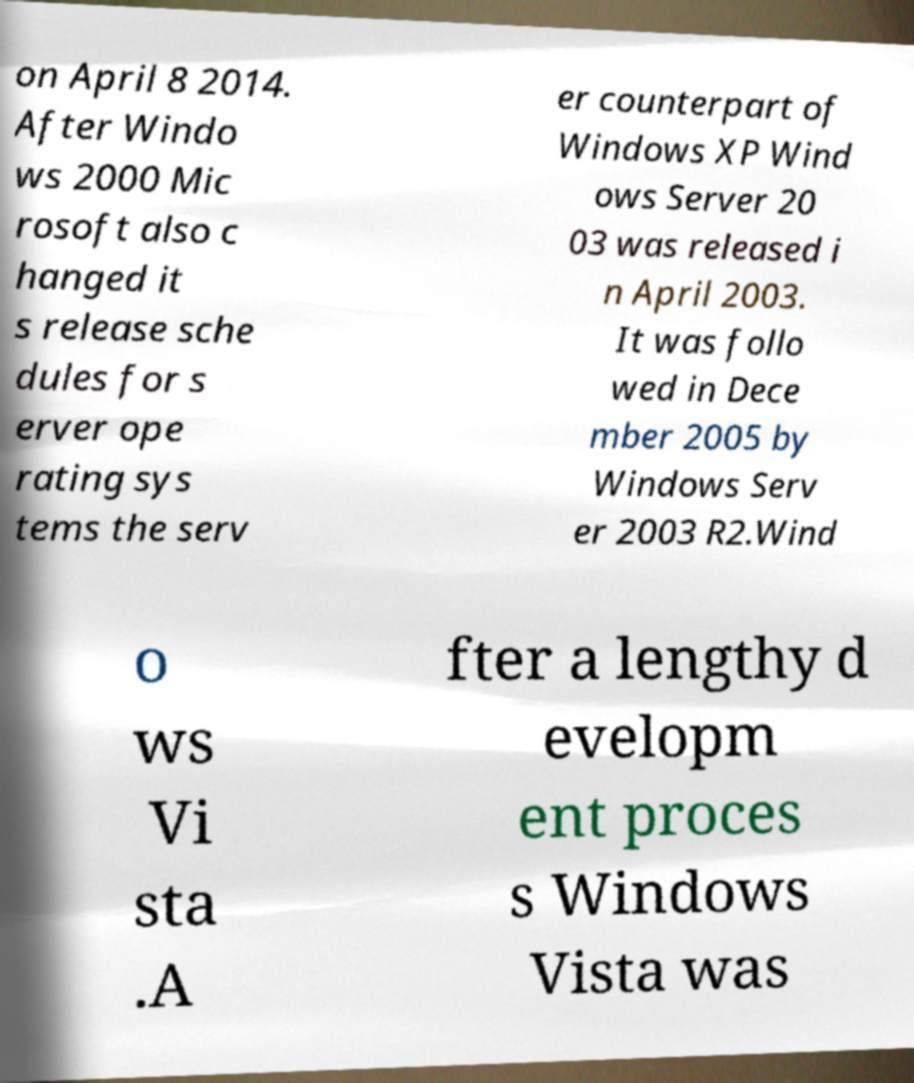I need the written content from this picture converted into text. Can you do that? on April 8 2014. After Windo ws 2000 Mic rosoft also c hanged it s release sche dules for s erver ope rating sys tems the serv er counterpart of Windows XP Wind ows Server 20 03 was released i n April 2003. It was follo wed in Dece mber 2005 by Windows Serv er 2003 R2.Wind o ws Vi sta .A fter a lengthy d evelopm ent proces s Windows Vista was 